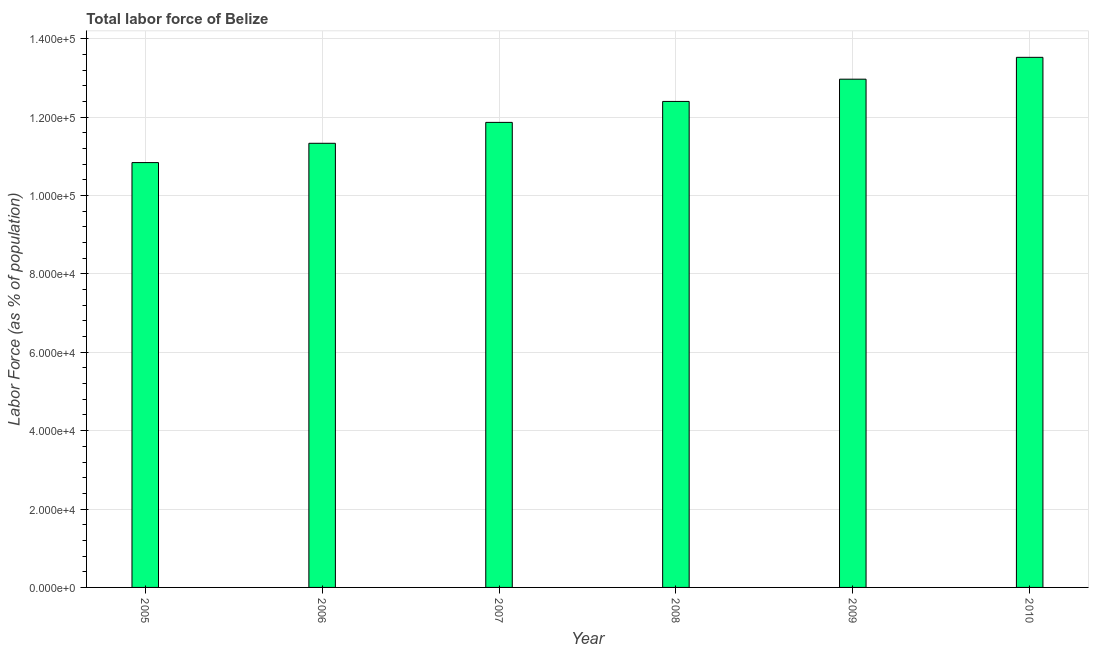Does the graph contain grids?
Keep it short and to the point. Yes. What is the title of the graph?
Give a very brief answer. Total labor force of Belize. What is the label or title of the Y-axis?
Your answer should be very brief. Labor Force (as % of population). What is the total labor force in 2006?
Ensure brevity in your answer.  1.13e+05. Across all years, what is the maximum total labor force?
Keep it short and to the point. 1.35e+05. Across all years, what is the minimum total labor force?
Offer a very short reply. 1.08e+05. In which year was the total labor force maximum?
Your answer should be compact. 2010. In which year was the total labor force minimum?
Offer a terse response. 2005. What is the sum of the total labor force?
Give a very brief answer. 7.29e+05. What is the difference between the total labor force in 2008 and 2010?
Provide a short and direct response. -1.13e+04. What is the average total labor force per year?
Make the answer very short. 1.22e+05. What is the median total labor force?
Give a very brief answer. 1.21e+05. In how many years, is the total labor force greater than 60000 %?
Your answer should be very brief. 6. Do a majority of the years between 2009 and 2007 (inclusive) have total labor force greater than 56000 %?
Your answer should be compact. Yes. What is the ratio of the total labor force in 2009 to that in 2010?
Provide a succinct answer. 0.96. Is the total labor force in 2007 less than that in 2008?
Offer a terse response. Yes. Is the difference between the total labor force in 2007 and 2008 greater than the difference between any two years?
Provide a succinct answer. No. What is the difference between the highest and the second highest total labor force?
Make the answer very short. 5574. What is the difference between the highest and the lowest total labor force?
Give a very brief answer. 2.69e+04. What is the difference between two consecutive major ticks on the Y-axis?
Provide a succinct answer. 2.00e+04. Are the values on the major ticks of Y-axis written in scientific E-notation?
Give a very brief answer. Yes. What is the Labor Force (as % of population) of 2005?
Give a very brief answer. 1.08e+05. What is the Labor Force (as % of population) in 2006?
Provide a succinct answer. 1.13e+05. What is the Labor Force (as % of population) in 2007?
Keep it short and to the point. 1.19e+05. What is the Labor Force (as % of population) in 2008?
Make the answer very short. 1.24e+05. What is the Labor Force (as % of population) of 2009?
Provide a succinct answer. 1.30e+05. What is the Labor Force (as % of population) of 2010?
Provide a short and direct response. 1.35e+05. What is the difference between the Labor Force (as % of population) in 2005 and 2006?
Provide a short and direct response. -4924. What is the difference between the Labor Force (as % of population) in 2005 and 2007?
Your answer should be compact. -1.03e+04. What is the difference between the Labor Force (as % of population) in 2005 and 2008?
Provide a short and direct response. -1.56e+04. What is the difference between the Labor Force (as % of population) in 2005 and 2009?
Give a very brief answer. -2.13e+04. What is the difference between the Labor Force (as % of population) in 2005 and 2010?
Your answer should be very brief. -2.69e+04. What is the difference between the Labor Force (as % of population) in 2006 and 2007?
Your answer should be very brief. -5334. What is the difference between the Labor Force (as % of population) in 2006 and 2008?
Offer a very short reply. -1.07e+04. What is the difference between the Labor Force (as % of population) in 2006 and 2009?
Provide a succinct answer. -1.64e+04. What is the difference between the Labor Force (as % of population) in 2006 and 2010?
Your answer should be compact. -2.19e+04. What is the difference between the Labor Force (as % of population) in 2007 and 2008?
Give a very brief answer. -5347. What is the difference between the Labor Force (as % of population) in 2007 and 2009?
Make the answer very short. -1.10e+04. What is the difference between the Labor Force (as % of population) in 2007 and 2010?
Your response must be concise. -1.66e+04. What is the difference between the Labor Force (as % of population) in 2008 and 2009?
Your answer should be very brief. -5678. What is the difference between the Labor Force (as % of population) in 2008 and 2010?
Offer a very short reply. -1.13e+04. What is the difference between the Labor Force (as % of population) in 2009 and 2010?
Keep it short and to the point. -5574. What is the ratio of the Labor Force (as % of population) in 2005 to that in 2007?
Provide a succinct answer. 0.91. What is the ratio of the Labor Force (as % of population) in 2005 to that in 2008?
Your answer should be very brief. 0.87. What is the ratio of the Labor Force (as % of population) in 2005 to that in 2009?
Provide a succinct answer. 0.84. What is the ratio of the Labor Force (as % of population) in 2005 to that in 2010?
Your response must be concise. 0.8. What is the ratio of the Labor Force (as % of population) in 2006 to that in 2007?
Give a very brief answer. 0.95. What is the ratio of the Labor Force (as % of population) in 2006 to that in 2008?
Offer a terse response. 0.91. What is the ratio of the Labor Force (as % of population) in 2006 to that in 2009?
Your answer should be very brief. 0.87. What is the ratio of the Labor Force (as % of population) in 2006 to that in 2010?
Your answer should be compact. 0.84. What is the ratio of the Labor Force (as % of population) in 2007 to that in 2008?
Your response must be concise. 0.96. What is the ratio of the Labor Force (as % of population) in 2007 to that in 2009?
Ensure brevity in your answer.  0.92. What is the ratio of the Labor Force (as % of population) in 2007 to that in 2010?
Your response must be concise. 0.88. What is the ratio of the Labor Force (as % of population) in 2008 to that in 2009?
Your response must be concise. 0.96. What is the ratio of the Labor Force (as % of population) in 2008 to that in 2010?
Your answer should be very brief. 0.92. 